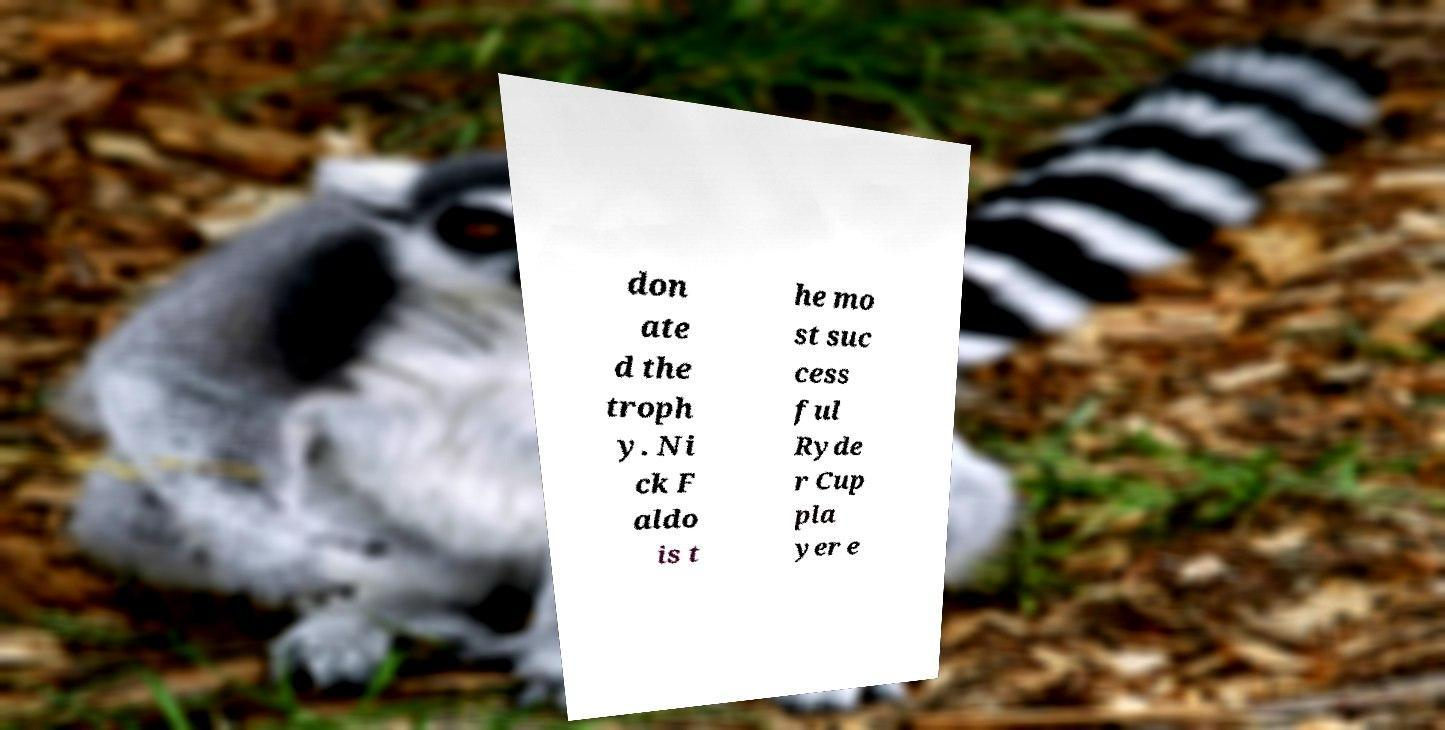What messages or text are displayed in this image? I need them in a readable, typed format. don ate d the troph y. Ni ck F aldo is t he mo st suc cess ful Ryde r Cup pla yer e 